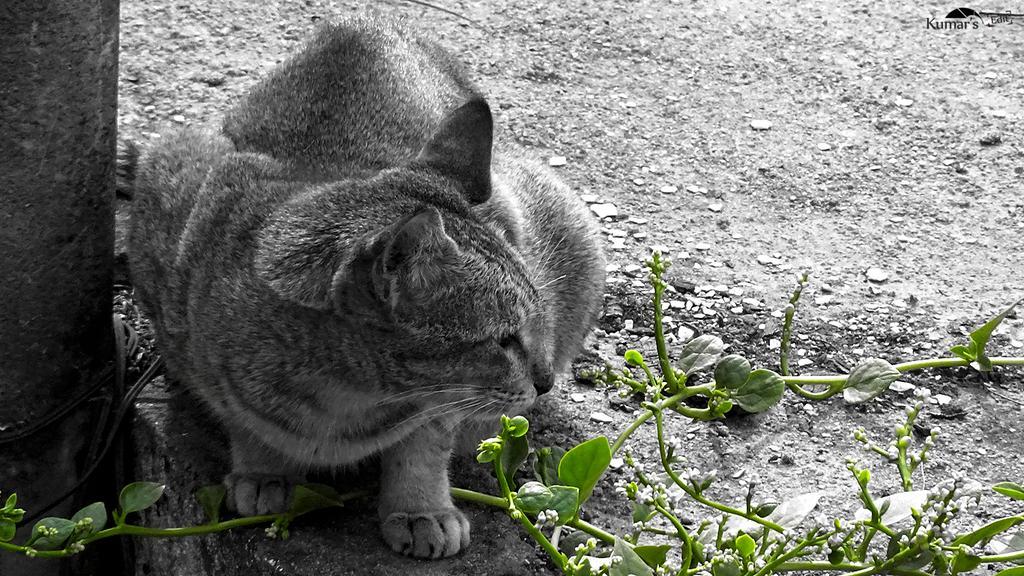Describe this image in one or two sentences. This is a black and white image. In this image, on the left side, we can see a cat sitting on the land. On the left side, we can also see a wooden trunk. At the bottom, we can see some green leaf and a land with some stones. 